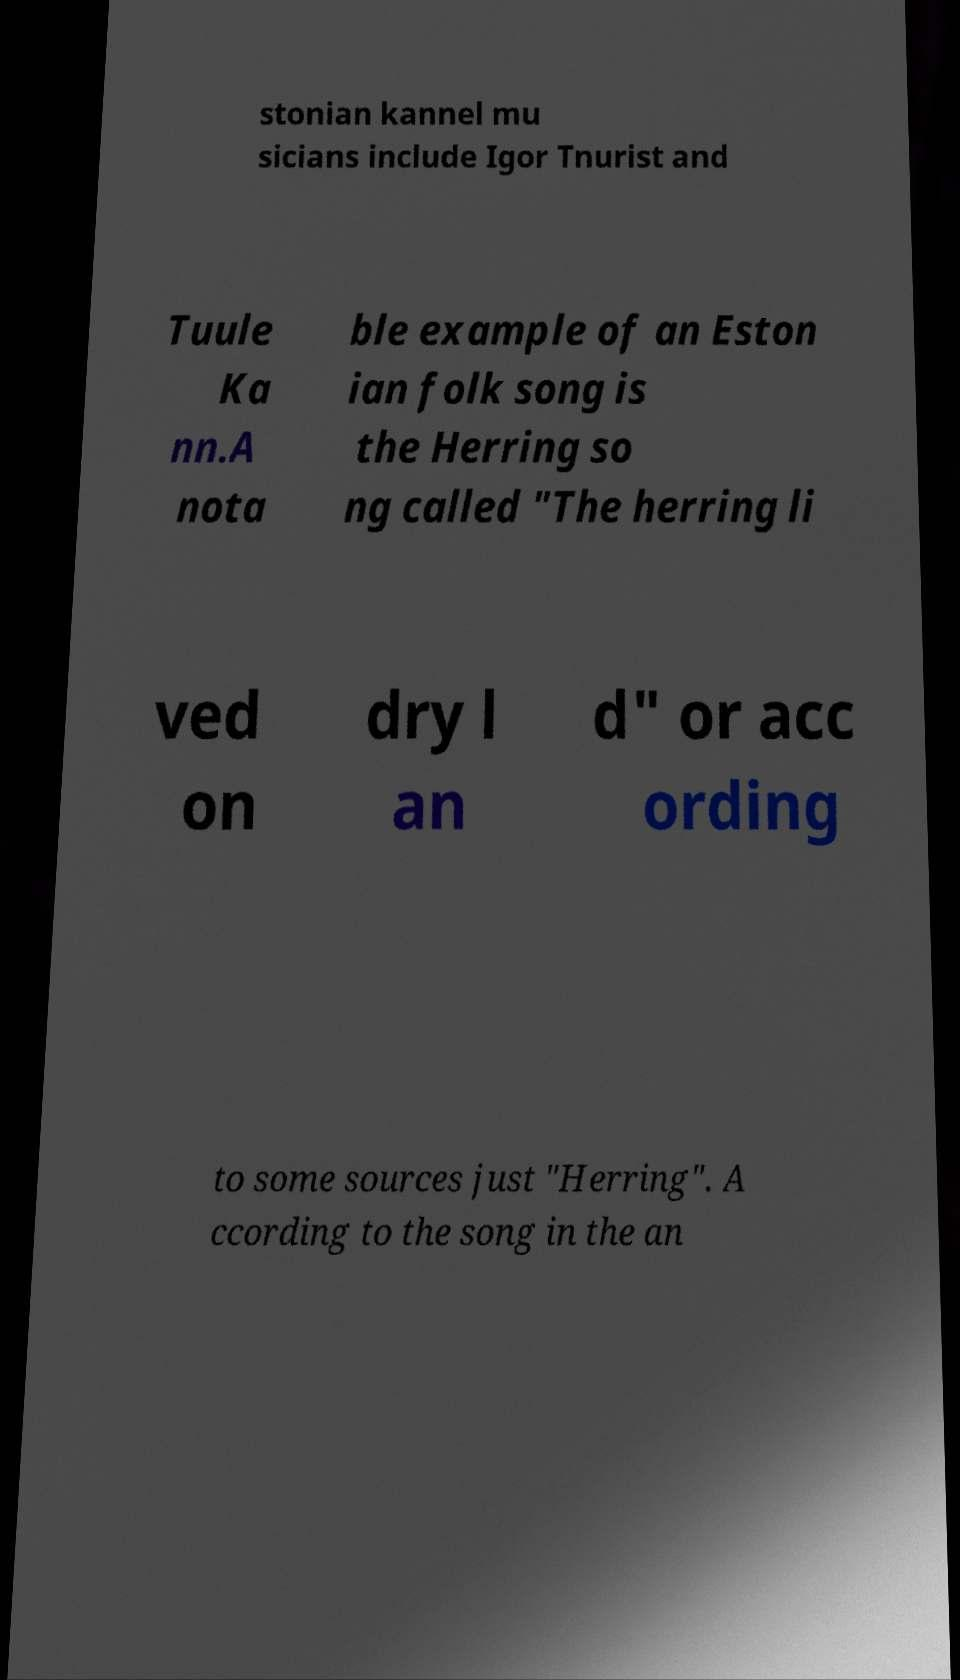What messages or text are displayed in this image? I need them in a readable, typed format. stonian kannel mu sicians include Igor Tnurist and Tuule Ka nn.A nota ble example of an Eston ian folk song is the Herring so ng called "The herring li ved on dry l an d" or acc ording to some sources just "Herring". A ccording to the song in the an 